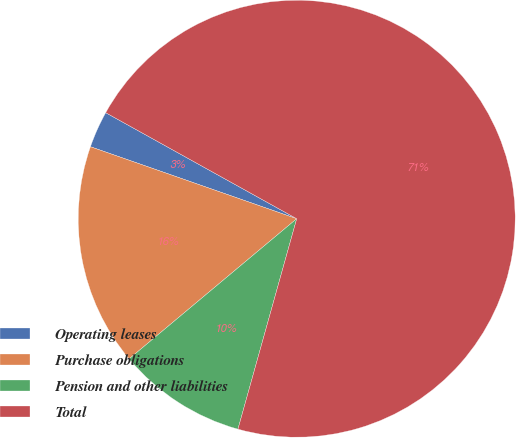Convert chart to OTSL. <chart><loc_0><loc_0><loc_500><loc_500><pie_chart><fcel>Operating leases<fcel>Purchase obligations<fcel>Pension and other liabilities<fcel>Total<nl><fcel>2.72%<fcel>16.43%<fcel>9.58%<fcel>71.27%<nl></chart> 